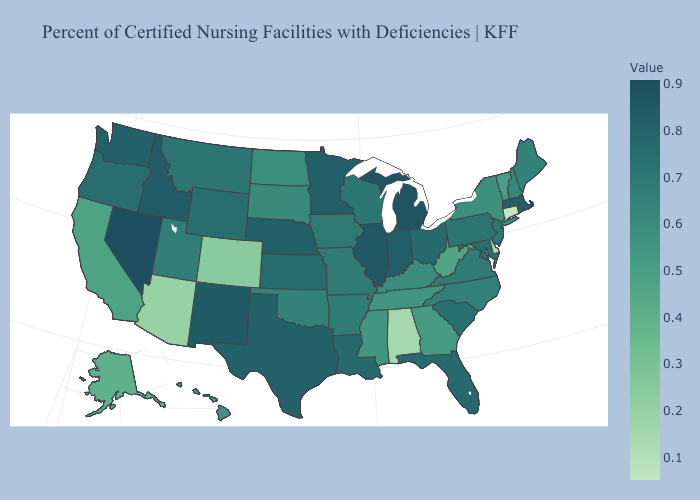Does Connecticut have the lowest value in the Northeast?
Give a very brief answer. Yes. Among the states that border Colorado , does New Mexico have the lowest value?
Quick response, please. No. Is the legend a continuous bar?
Keep it brief. Yes. Does the map have missing data?
Be succinct. No. Does South Dakota have the highest value in the MidWest?
Keep it brief. No. 